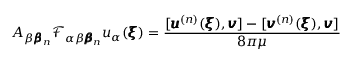<formula> <loc_0><loc_0><loc_500><loc_500>A _ { \beta { \pm b \beta } _ { n } } \mathcal { F } _ { \alpha \beta { \pm b \beta } _ { n } } u _ { \alpha } ( { \pm b \xi } ) = \frac { [ { \pm b u } ^ { ( n ) } ( { \pm b \xi } ) , { \pm b v } ] - [ { \pm b v } ^ { ( n ) } ( { \pm b \xi } ) , { \pm b v } ] } { 8 \pi \mu }</formula> 